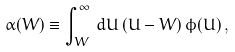Convert formula to latex. <formula><loc_0><loc_0><loc_500><loc_500>\alpha ( W ) \equiv \int _ { W } ^ { \infty } \, d U \, ( U - W ) \, \phi ( U ) \, ,</formula> 